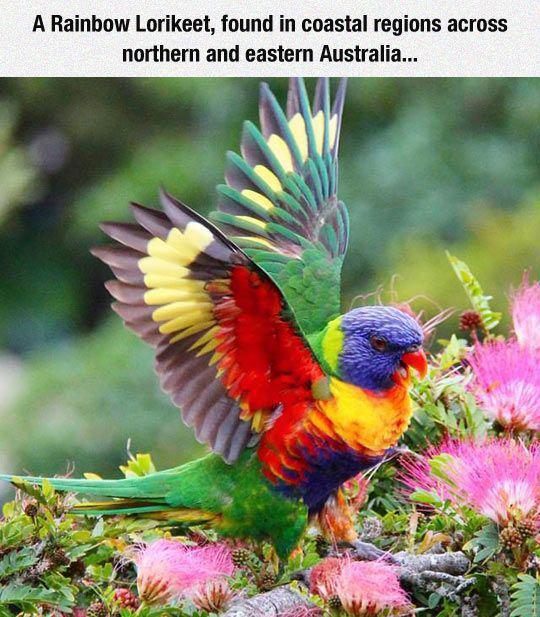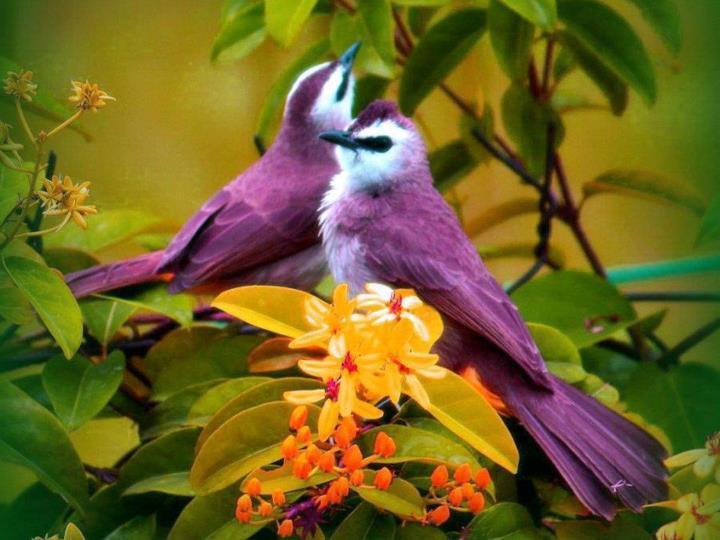The first image is the image on the left, the second image is the image on the right. Given the left and right images, does the statement "Two birds share a branch in the image on the right." hold true? Answer yes or no. Yes. 